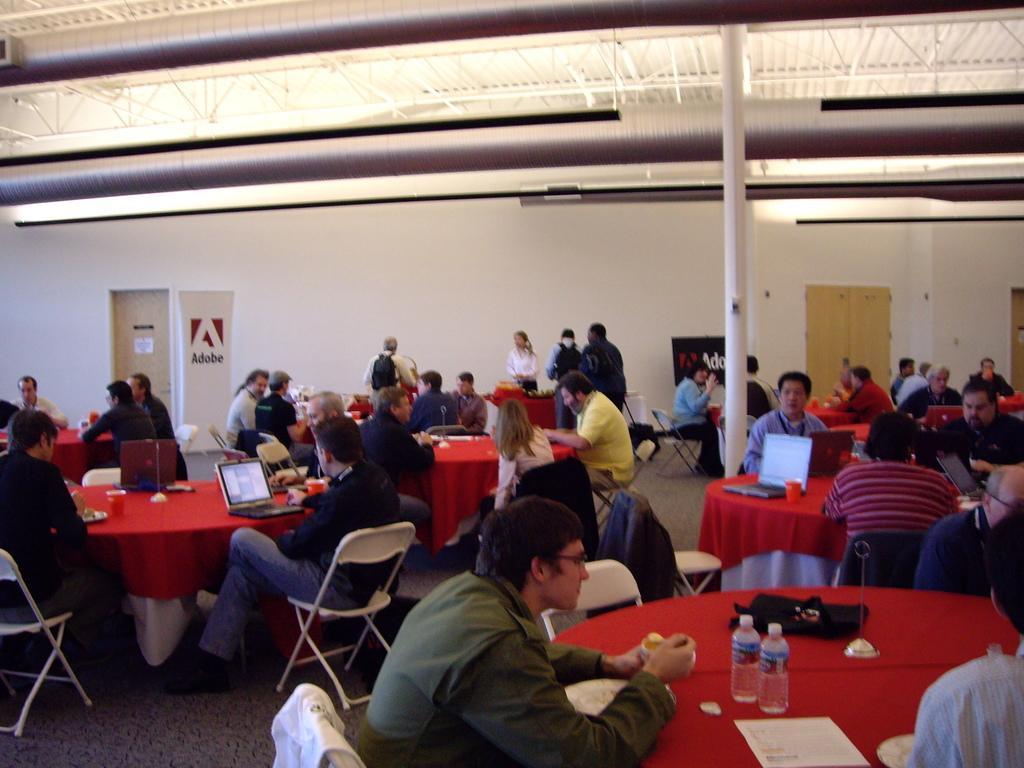In one or two sentences, can you explain what this image depicts? In this picture we can see a group of people sitting on chair and in front of them there is table and on table we can see bottle, bag, paper, laptop and in background we can see wall, doors, banner, pole. 